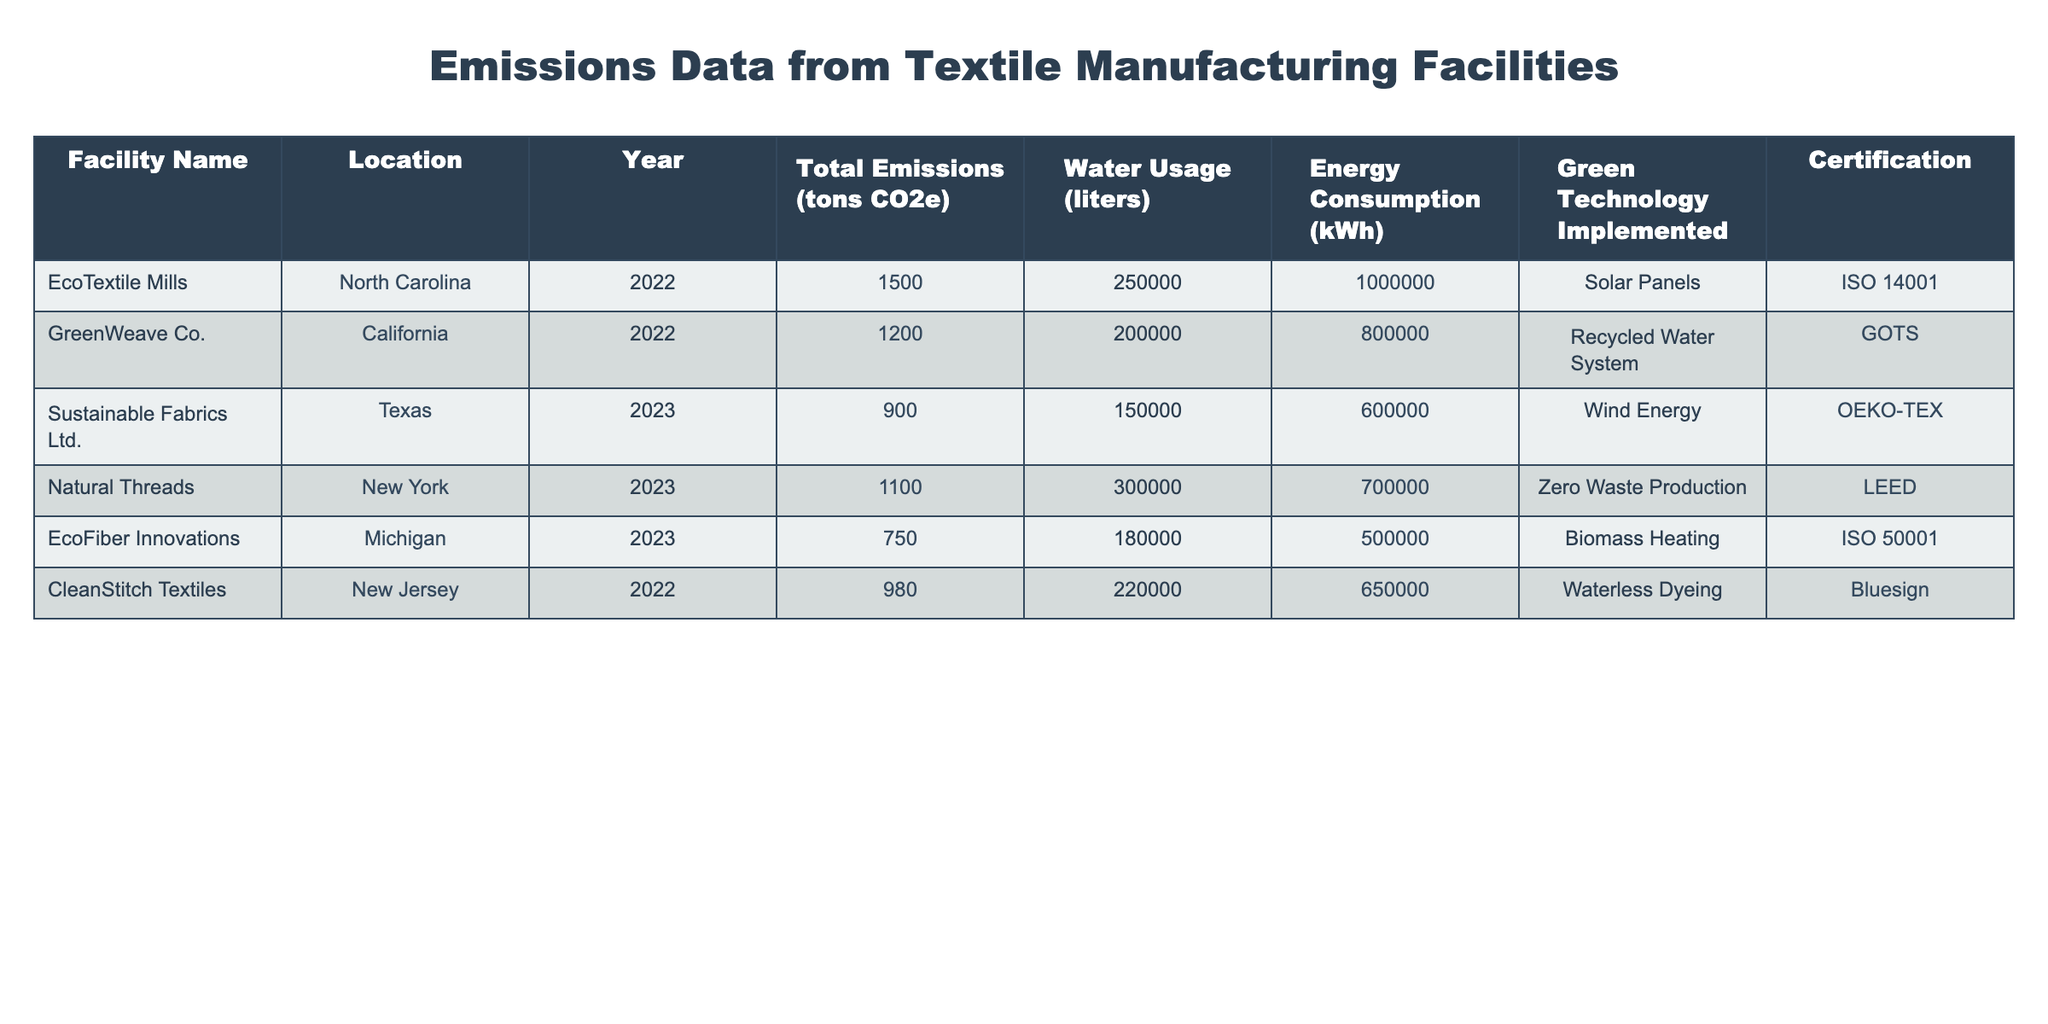What is the total emissions from EcoFiber Innovations? EcoFiber Innovations is listed in the table with total emissions of 750 tons CO2e.
Answer: 750 tons CO2e Which facility has the highest water usage? Looking at the 'Water Usage' column, Natural Threads has the highest water usage at 300,000 liters.
Answer: Natural Threads What is the average energy consumption of the facilities listed? To find the average energy consumption, sum up the energy consumption values (1,000,000 + 800,000 + 600,000 + 700,000 + 500,000 + 650,000 = 3,250,000 kWh), then divide by the number of facilities (6). The average is 3,250,000 kWh / 6 = approximately 541,666.67 kWh.
Answer: 541,666.67 kWh Is there any facility that has achieved a Green Technology certification? Yes, all six facilities in the table have achieved a certification related to their green technologies as indicated in the last column.
Answer: Yes Which facility implemented a waterless dyeing technology and what were its total emissions? CleanStitch Textiles implemented a waterless dyeing technology and it had total emissions of 980 tons CO2e, as shown in the corresponding entries in the table.
Answer: CleanStitch Textiles, 980 tons CO2e What is the difference in total emissions between Sustainable Fabrics Ltd. and GreenWeave Co.? Sustainable Fabrics Ltd. has total emissions of 900 tons CO2e and GreenWeave Co. has 1200 tons CO2e. The difference is 1200 - 900 = 300 tons CO2e.
Answer: 300 tons CO2e What is the total water usage of all facilities combined? To calculate the total water usage, we add up the water usage values (250,000 + 200,000 + 150,000 + 300,000 + 180,000 + 220,000 = 1,300,000 liters).
Answer: 1,300,000 liters Which facility consumes the least amount of energy, and how much is it? EcoFiber Innovations consumes the least energy at 500,000 kWh, as we can see in the 'Energy Consumption' column.
Answer: EcoFiber Innovations, 500,000 kWh Are there any facilities that implemented two types of green technologies? No, the data indicates that each facility implemented one specific type of green technology only, as seen in the 'Green Technology Implemented' column.
Answer: No 